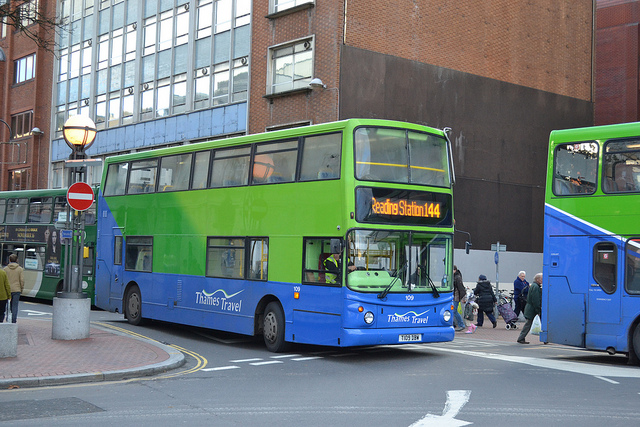Read all the text in this image. Reading Station 144 Thames Travel Travel Thames 